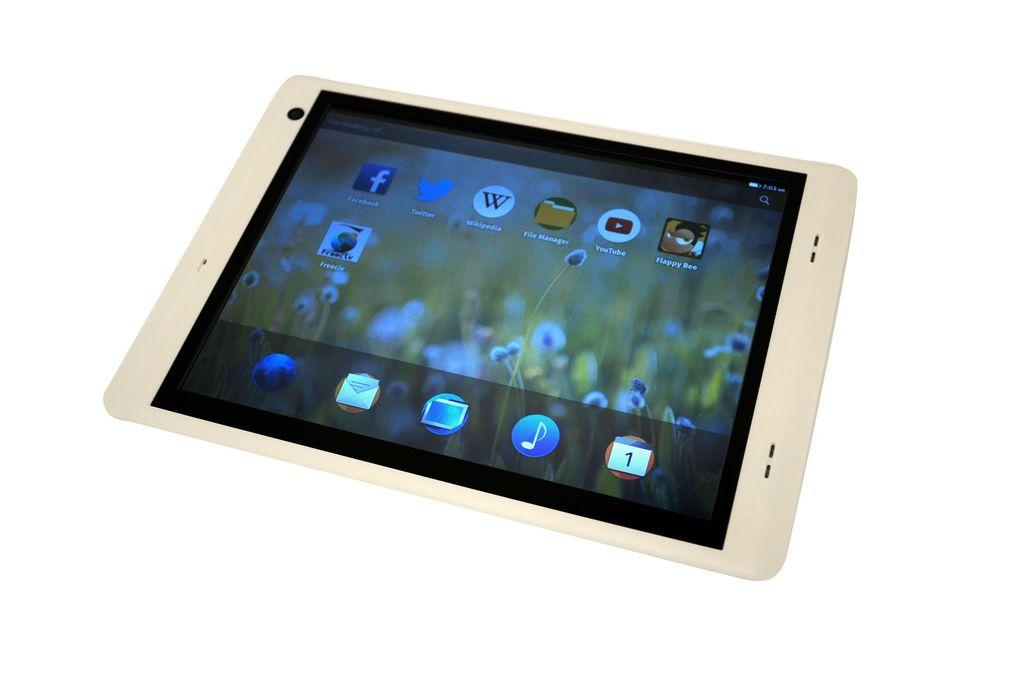What is the main object in the center of the image? There is a tab in the center of the image. What feature does the tab have? The tab has a screen. What can be seen on the tab screen? There are applications visible on the tab screen. What color is the background of the tab screen? The background of the tab screen is white. How much profit can be made from the can in the image? There is no can present in the image, so it is not possible to determine any potential profit. 